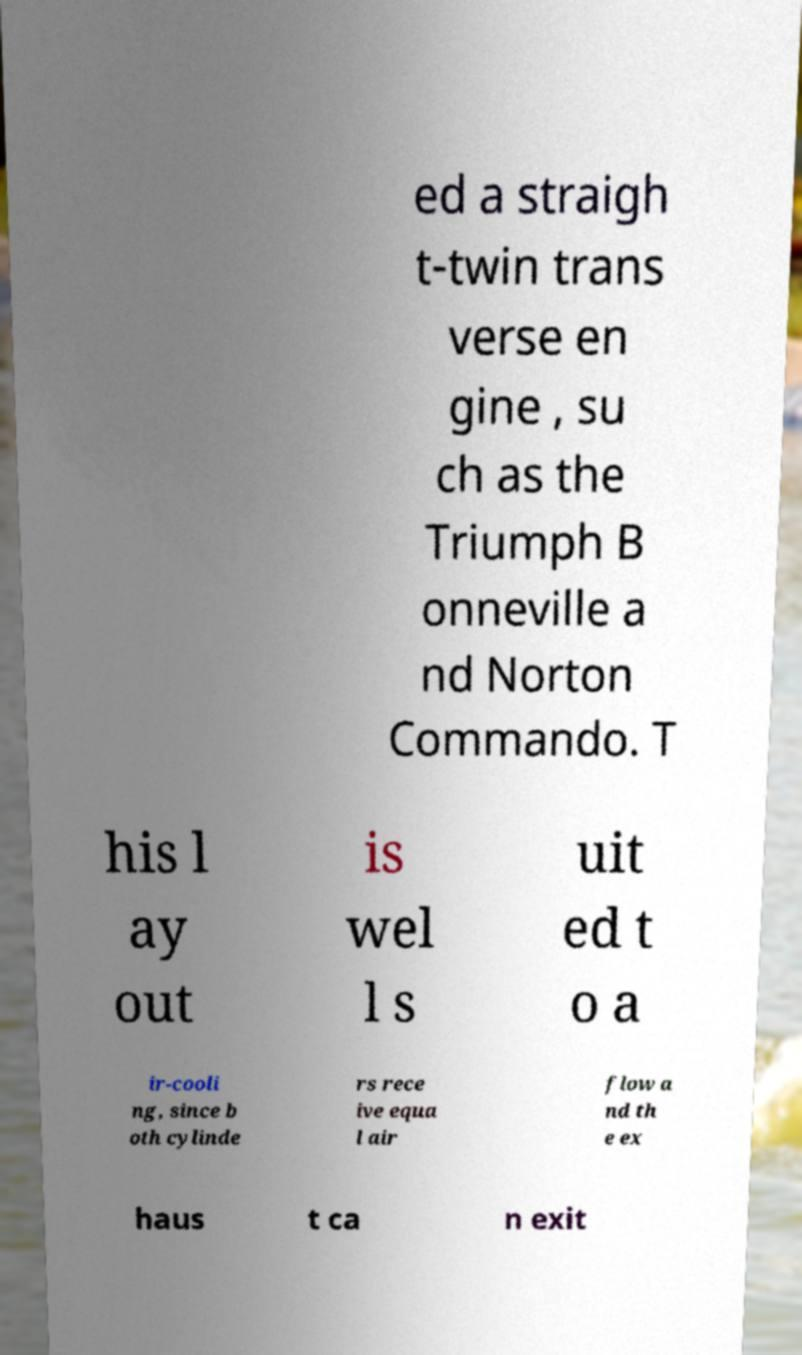Can you read and provide the text displayed in the image?This photo seems to have some interesting text. Can you extract and type it out for me? ed a straigh t-twin trans verse en gine , su ch as the Triumph B onneville a nd Norton Commando. T his l ay out is wel l s uit ed t o a ir-cooli ng, since b oth cylinde rs rece ive equa l air flow a nd th e ex haus t ca n exit 